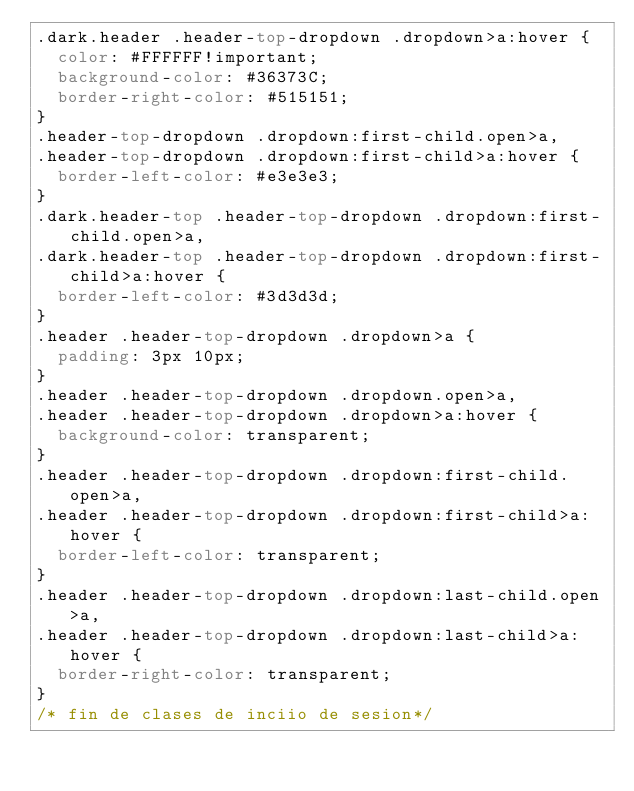<code> <loc_0><loc_0><loc_500><loc_500><_CSS_>.dark.header .header-top-dropdown .dropdown>a:hover {
	color: #FFFFFF!important;
	background-color: #36373C;
	border-right-color: #515151;
}
.header-top-dropdown .dropdown:first-child.open>a,
.header-top-dropdown .dropdown:first-child>a:hover {
	border-left-color: #e3e3e3;
}
.dark.header-top .header-top-dropdown .dropdown:first-child.open>a,
.dark.header-top .header-top-dropdown .dropdown:first-child>a:hover {
	border-left-color: #3d3d3d;
}
.header .header-top-dropdown .dropdown>a {
	padding: 3px 10px;
}
.header .header-top-dropdown .dropdown.open>a,
.header .header-top-dropdown .dropdown>a:hover {
	background-color: transparent;
}
.header .header-top-dropdown .dropdown:first-child.open>a,
.header .header-top-dropdown .dropdown:first-child>a:hover {
	border-left-color: transparent;
}
.header .header-top-dropdown .dropdown:last-child.open>a,
.header .header-top-dropdown .dropdown:last-child>a:hover {
	border-right-color: transparent;
}
/* fin de clases de inciio de sesion*/</code> 